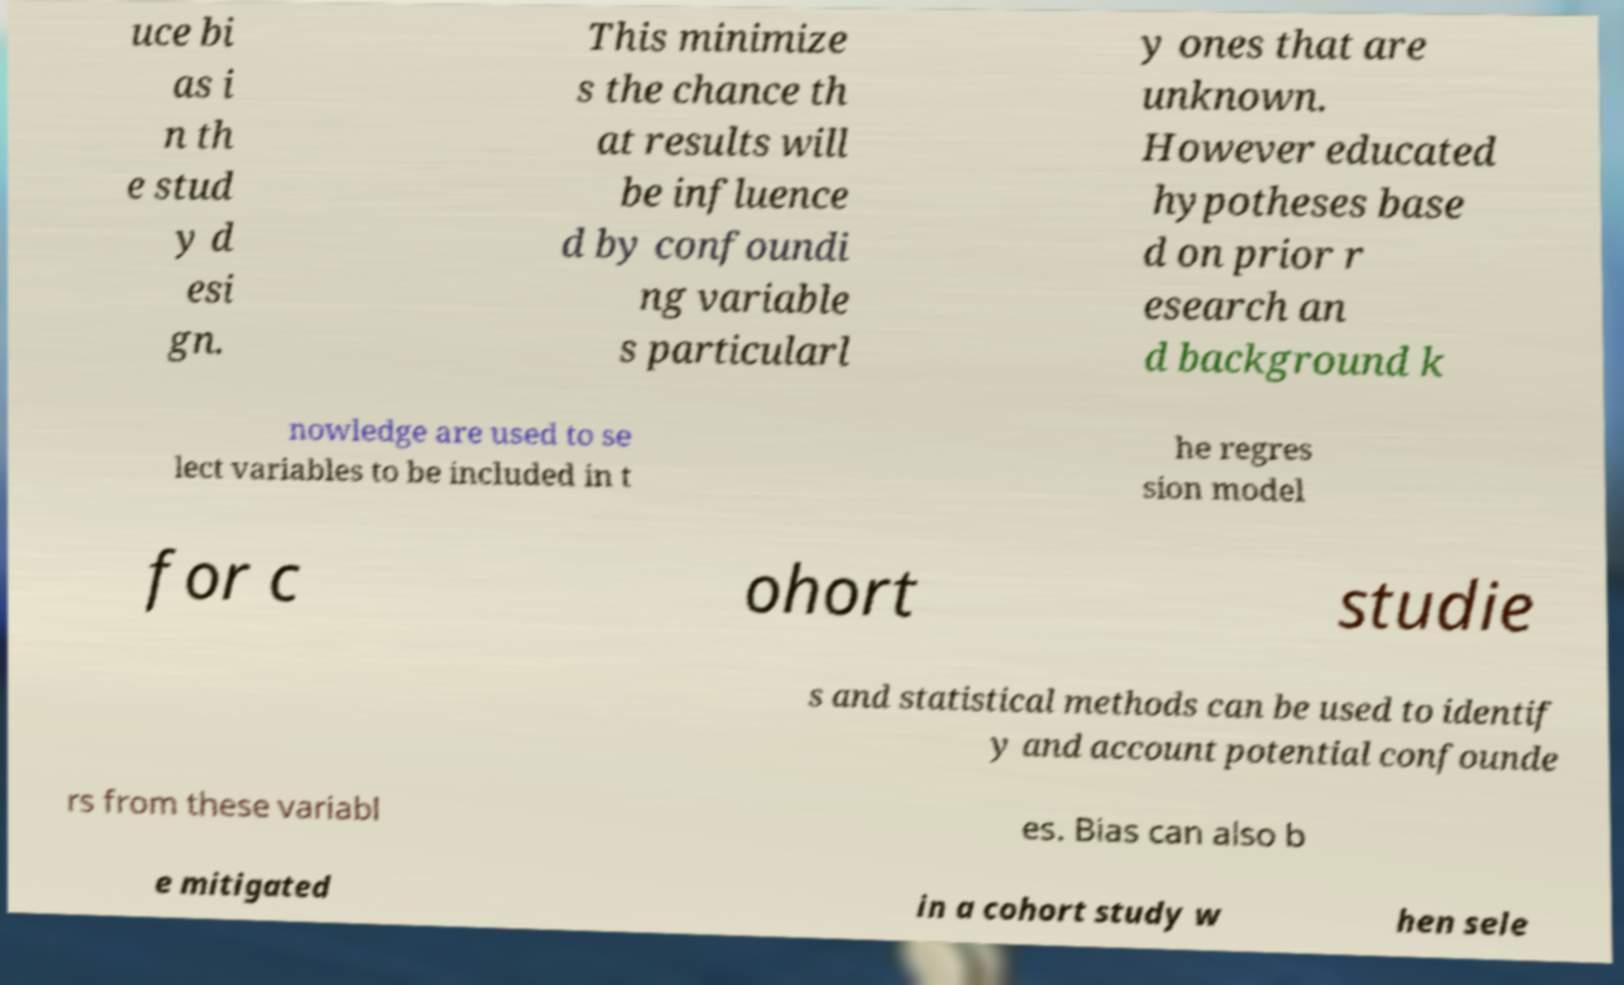Please read and relay the text visible in this image. What does it say? uce bi as i n th e stud y d esi gn. This minimize s the chance th at results will be influence d by confoundi ng variable s particularl y ones that are unknown. However educated hypotheses base d on prior r esearch an d background k nowledge are used to se lect variables to be included in t he regres sion model for c ohort studie s and statistical methods can be used to identif y and account potential confounde rs from these variabl es. Bias can also b e mitigated in a cohort study w hen sele 